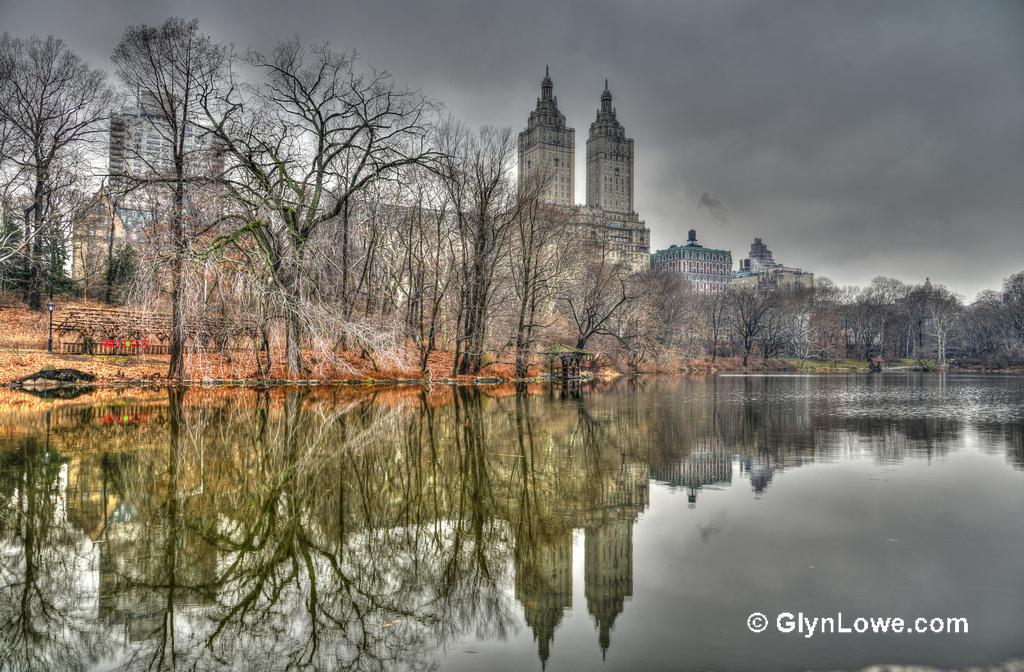What is one of the main elements in the image? There is water in the image. What type of natural elements can be seen in the image? There are trees in the image. What type of man-made structures are present in the image? There are buildings in the image. What type of street furniture can be seen in the image? There is a light pole in the image. What type of objects are present in the image? There are objects in the image. What can be seen in the background of the image? The sky is visible in the background of the image. What type of weather condition can be inferred from the image? Clouds are present in the sky, suggesting a partly cloudy day. Where is the drawer located in the image? There is no drawer present in the image. What type of zipper can be seen on the trees in the image? There are no zippers present on the trees in the image. 